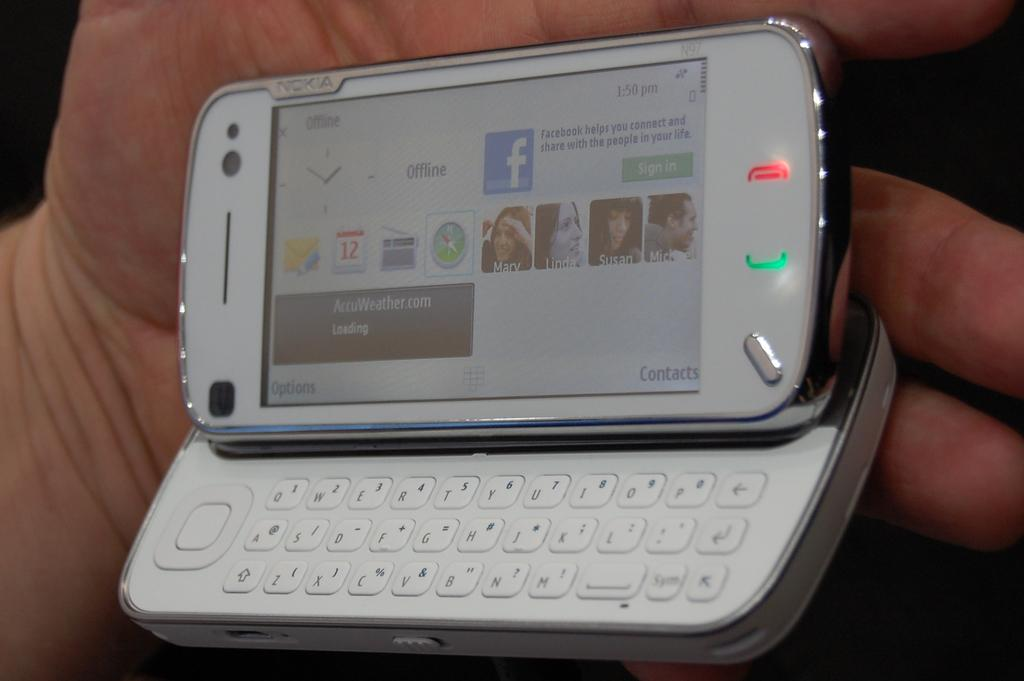Provide a one-sentence caption for the provided image. a slider phone showing that it is OFFLINE at 1:50 PM. 